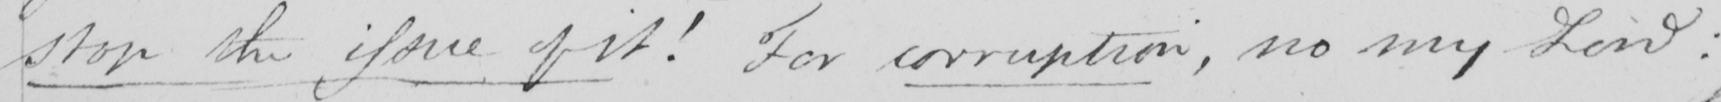What is written in this line of handwriting? stop the issue of it !  For corruption , no my Lord : 